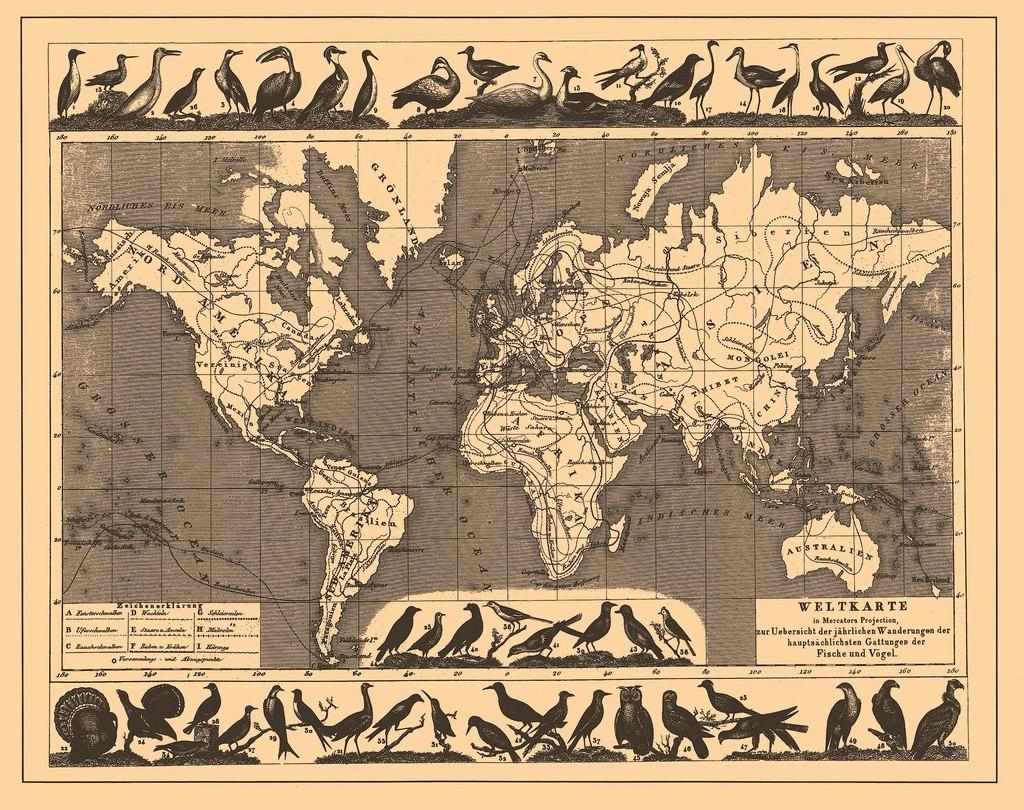<image>
Provide a brief description of the given image. A world mapped is marked as being made by Weltkarte. 